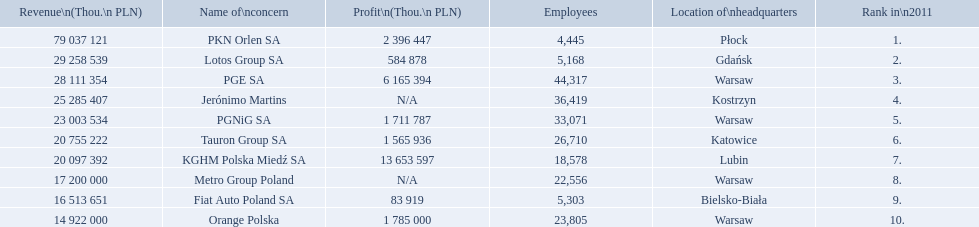What is the difference in employees for rank 1 and rank 3? 39,872 employees. 